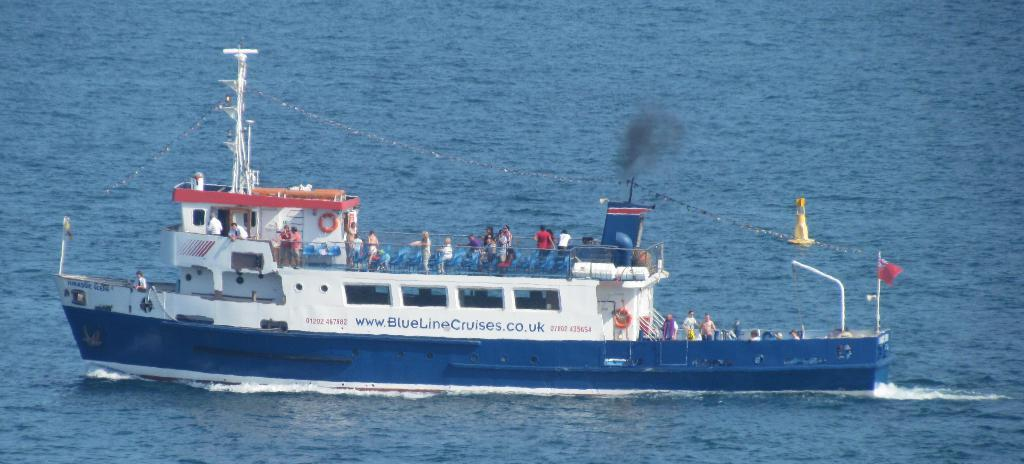What is the main subject of the image? The main subject of the image is a boat. What colors can be seen on the boat? The boat is blue and white in color. Where is the boat located in the image? The boat is on the surface of the water. Are there any people on the boat? Yes, there are people on the boat. What else can be seen in the image besides the boat and people? There is a flag and a yellow-colored object in the image. How many babies are crawling on the roof of the boat in the image? There are no babies or roof present in the image; it features a boat on the water with people and other objects. 